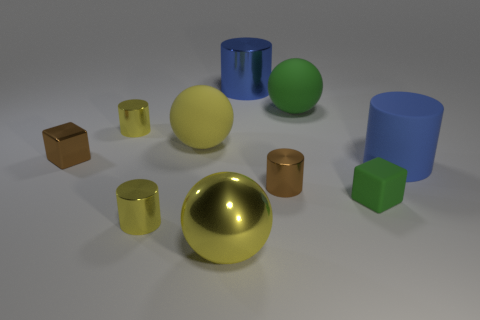Subtract all yellow balls. How many balls are left? 1 Subtract all blue cylinders. How many cylinders are left? 3 Subtract 4 cylinders. How many cylinders are left? 1 Subtract all red blocks. How many yellow cylinders are left? 2 Subtract 0 cyan blocks. How many objects are left? 10 Subtract all spheres. How many objects are left? 7 Subtract all purple cubes. Subtract all red balls. How many cubes are left? 2 Subtract all blue matte objects. Subtract all small yellow shiny objects. How many objects are left? 7 Add 8 big yellow rubber objects. How many big yellow rubber objects are left? 9 Add 10 gray rubber things. How many gray rubber things exist? 10 